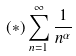<formula> <loc_0><loc_0><loc_500><loc_500>( * ) \sum _ { n = 1 } ^ { \infty } \frac { 1 } { n ^ { \alpha } }</formula> 